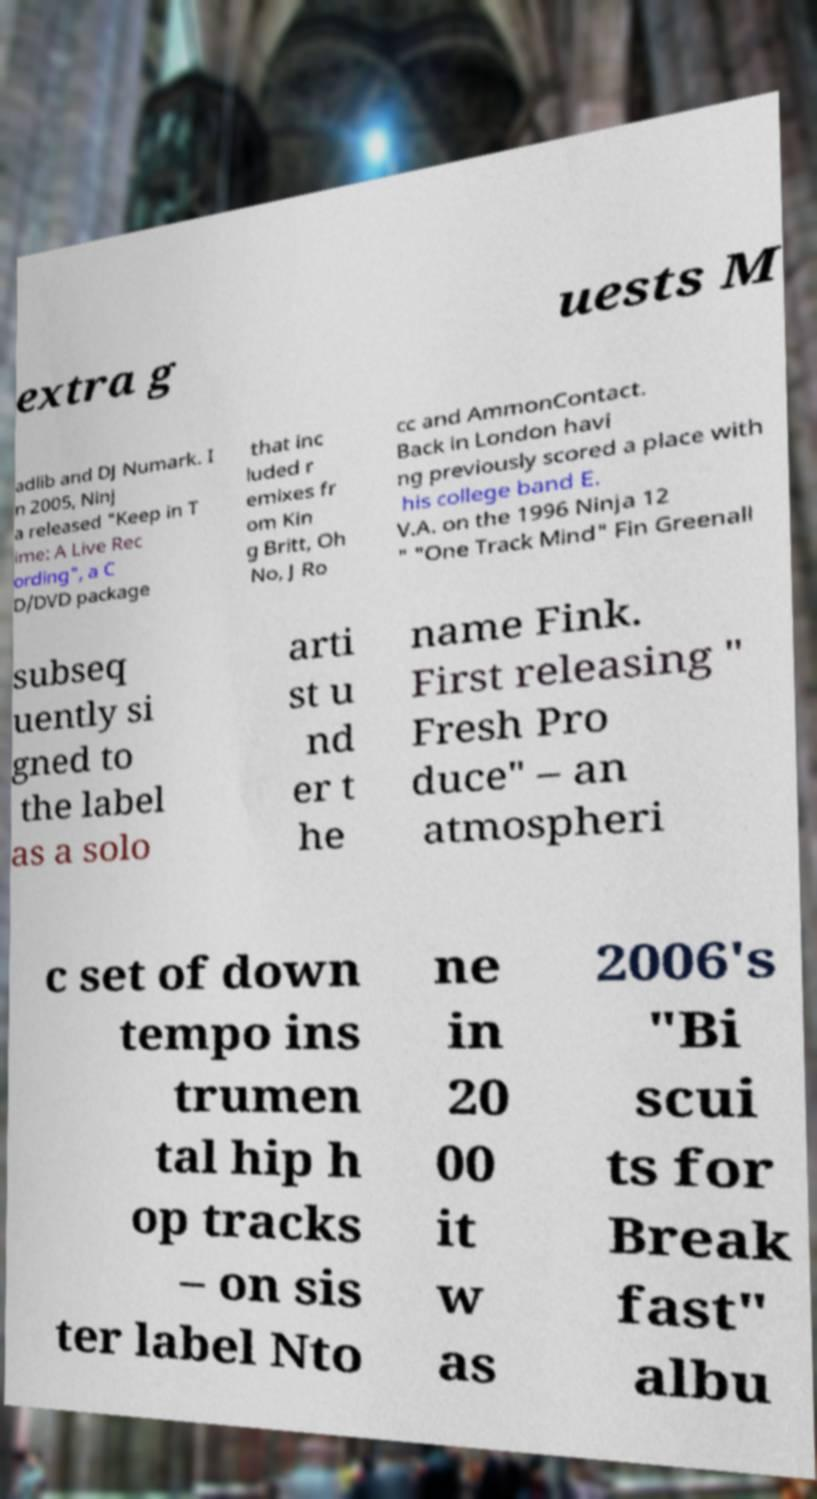There's text embedded in this image that I need extracted. Can you transcribe it verbatim? extra g uests M adlib and DJ Numark. I n 2005, Ninj a released "Keep in T ime: A Live Rec ording", a C D/DVD package that inc luded r emixes fr om Kin g Britt, Oh No, J Ro cc and AmmonContact. Back in London havi ng previously scored a place with his college band E. V.A. on the 1996 Ninja 12 " "One Track Mind" Fin Greenall subseq uently si gned to the label as a solo arti st u nd er t he name Fink. First releasing " Fresh Pro duce" – an atmospheri c set of down tempo ins trumen tal hip h op tracks – on sis ter label Nto ne in 20 00 it w as 2006's "Bi scui ts for Break fast" albu 